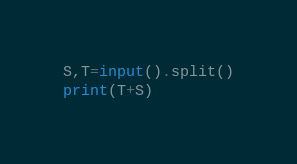<code> <loc_0><loc_0><loc_500><loc_500><_Python_>S,T=input().split()
print(T+S)</code> 